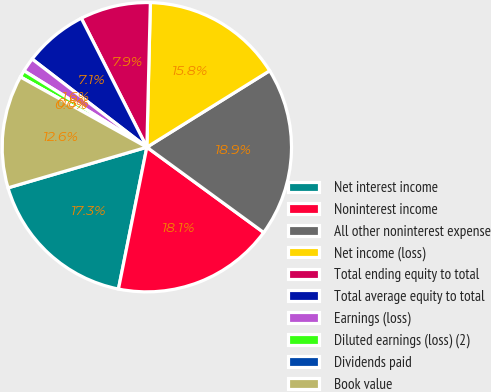Convert chart to OTSL. <chart><loc_0><loc_0><loc_500><loc_500><pie_chart><fcel>Net interest income<fcel>Noninterest income<fcel>All other noninterest expense<fcel>Net income (loss)<fcel>Total ending equity to total<fcel>Total average equity to total<fcel>Earnings (loss)<fcel>Diluted earnings (loss) (2)<fcel>Dividends paid<fcel>Book value<nl><fcel>17.32%<fcel>18.11%<fcel>18.9%<fcel>15.75%<fcel>7.87%<fcel>7.09%<fcel>1.57%<fcel>0.79%<fcel>0.0%<fcel>12.6%<nl></chart> 